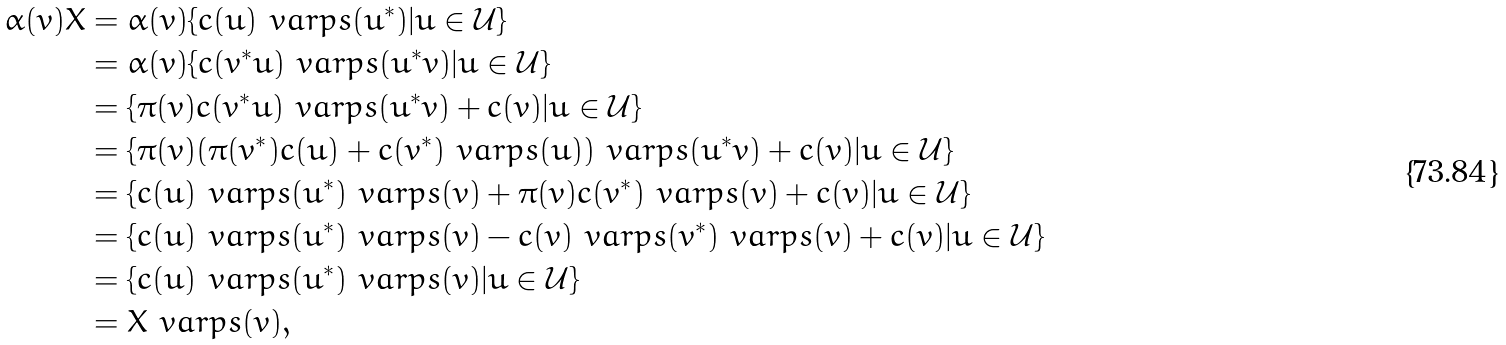<formula> <loc_0><loc_0><loc_500><loc_500>\alpha ( v ) X & = \alpha ( v ) \{ c ( u ) \ v a r p s ( u ^ { * } ) | u \in \mathcal { U } \} \\ & = \alpha ( v ) \{ c ( v ^ { * } u ) \ v a r p s ( u ^ { * } v ) | u \in \mathcal { U } \} \\ & = \{ \pi ( v ) c ( v ^ { * } u ) \ v a r p s ( u ^ { * } v ) + c ( v ) | u \in \mathcal { U } \} \\ & = \{ \pi ( v ) ( \pi ( v ^ { * } ) c ( u ) + c ( v ^ { * } ) \ v a r p s ( u ) ) \ v a r p s ( u ^ { * } v ) + c ( v ) | u \in \mathcal { U } \} \\ & = \{ c ( u ) \ v a r p s ( u ^ { * } ) \ v a r p s ( v ) + \pi ( v ) c ( v ^ { * } ) \ v a r p s ( v ) + c ( v ) | u \in \mathcal { U } \} \\ & = \{ c ( u ) \ v a r p s ( u ^ { * } ) \ v a r p s ( v ) - c ( v ) \ v a r p s ( v ^ { * } ) \ v a r p s ( v ) + c ( v ) | u \in \mathcal { U } \} \\ & = \{ c ( u ) \ v a r p s ( u ^ { * } ) \ v a r p s ( v ) | u \in \mathcal { U } \} \\ & = X \ v a r p s ( v ) ,</formula> 